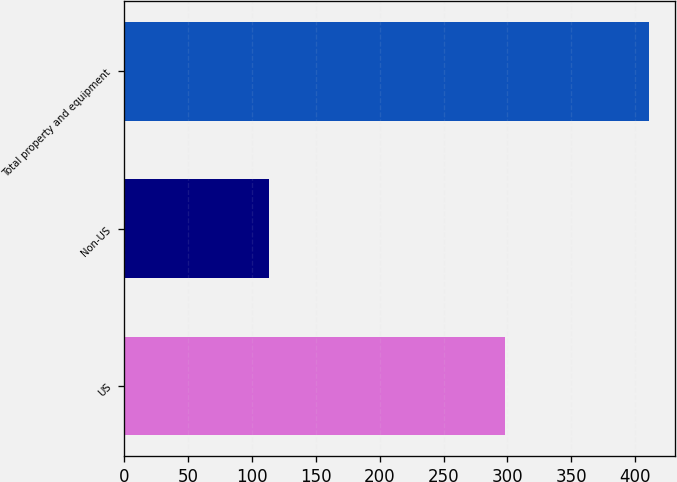<chart> <loc_0><loc_0><loc_500><loc_500><bar_chart><fcel>US<fcel>Non-US<fcel>Total property and equipment<nl><fcel>298<fcel>113<fcel>411<nl></chart> 